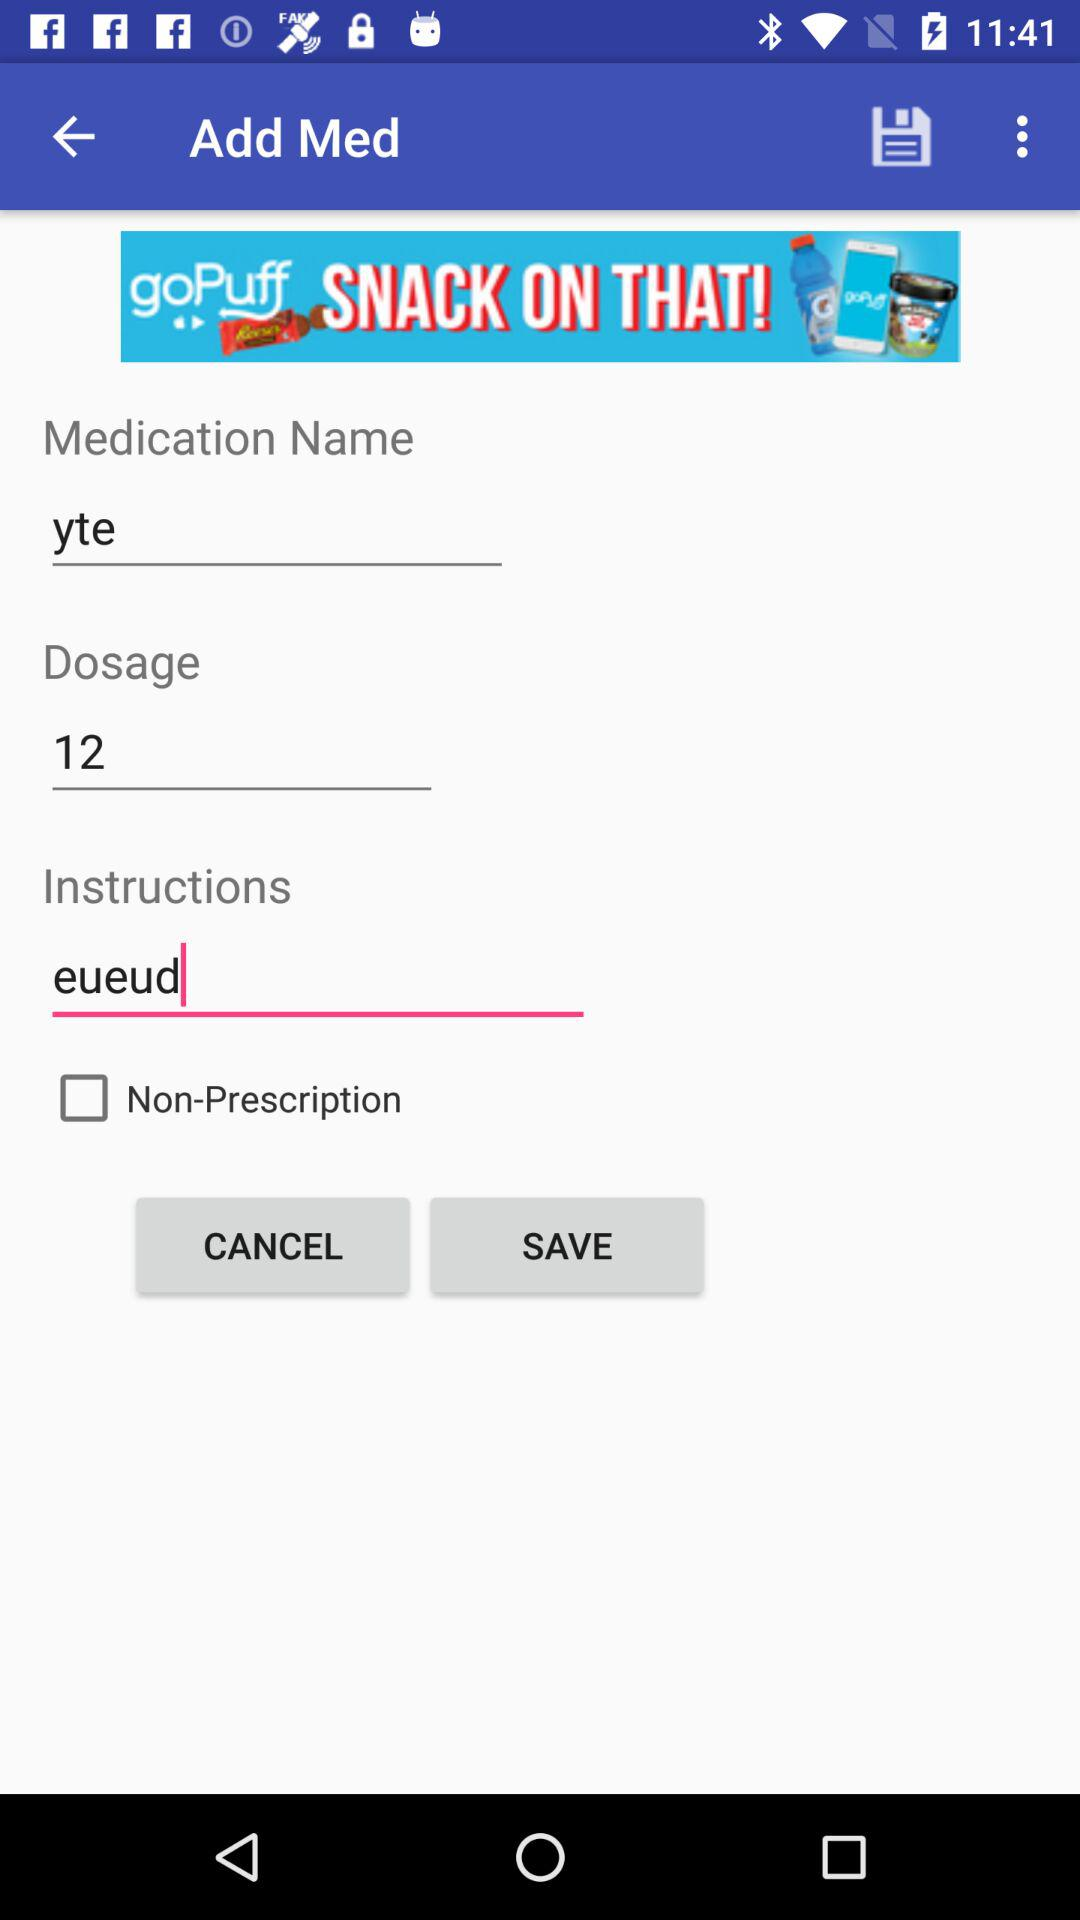What is the status of "Non-Prescription"? The status of "Non-Prescription" is "off". 